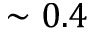<formula> <loc_0><loc_0><loc_500><loc_500>\sim 0 . 4</formula> 